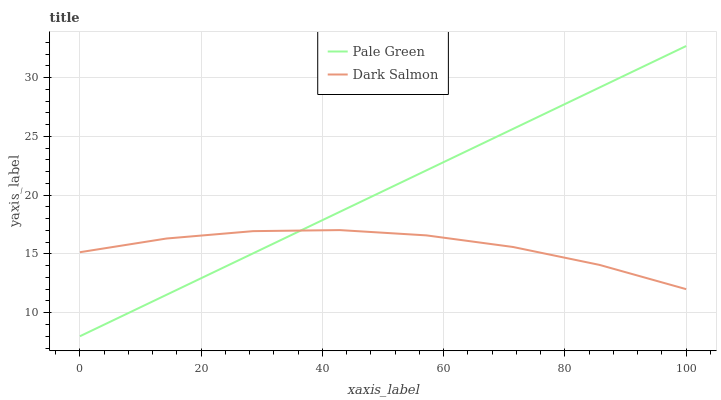Does Dark Salmon have the minimum area under the curve?
Answer yes or no. Yes. Does Pale Green have the maximum area under the curve?
Answer yes or no. Yes. Does Dark Salmon have the maximum area under the curve?
Answer yes or no. No. Is Pale Green the smoothest?
Answer yes or no. Yes. Is Dark Salmon the roughest?
Answer yes or no. Yes. Is Dark Salmon the smoothest?
Answer yes or no. No. Does Pale Green have the lowest value?
Answer yes or no. Yes. Does Dark Salmon have the lowest value?
Answer yes or no. No. Does Pale Green have the highest value?
Answer yes or no. Yes. Does Dark Salmon have the highest value?
Answer yes or no. No. Does Pale Green intersect Dark Salmon?
Answer yes or no. Yes. Is Pale Green less than Dark Salmon?
Answer yes or no. No. Is Pale Green greater than Dark Salmon?
Answer yes or no. No. 